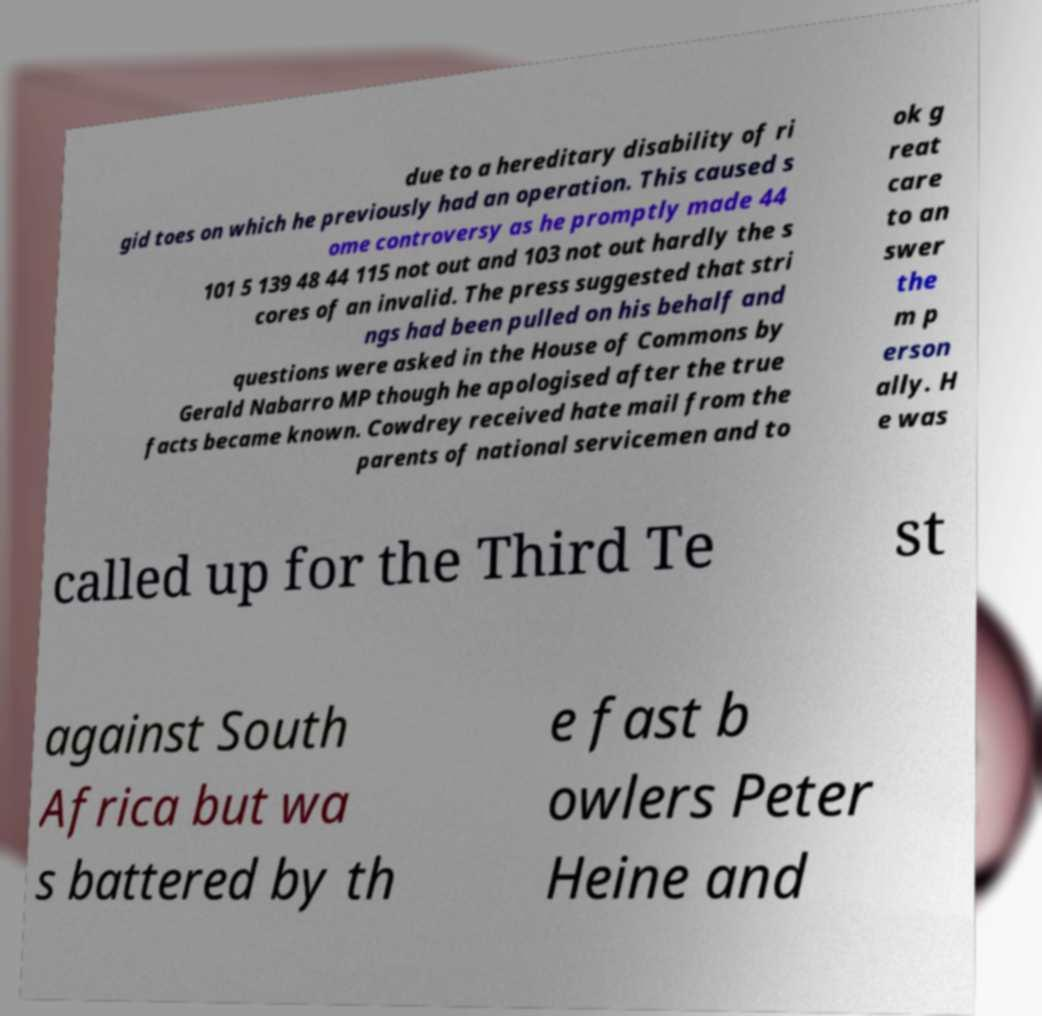Please read and relay the text visible in this image. What does it say? due to a hereditary disability of ri gid toes on which he previously had an operation. This caused s ome controversy as he promptly made 44 101 5 139 48 44 115 not out and 103 not out hardly the s cores of an invalid. The press suggested that stri ngs had been pulled on his behalf and questions were asked in the House of Commons by Gerald Nabarro MP though he apologised after the true facts became known. Cowdrey received hate mail from the parents of national servicemen and to ok g reat care to an swer the m p erson ally. H e was called up for the Third Te st against South Africa but wa s battered by th e fast b owlers Peter Heine and 